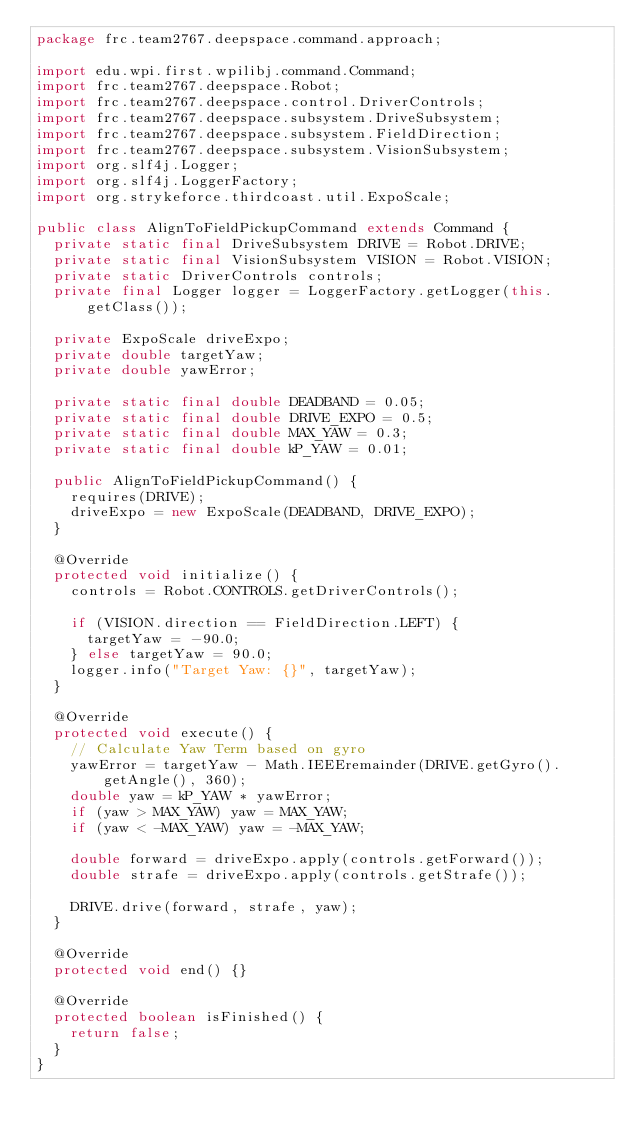<code> <loc_0><loc_0><loc_500><loc_500><_Java_>package frc.team2767.deepspace.command.approach;

import edu.wpi.first.wpilibj.command.Command;
import frc.team2767.deepspace.Robot;
import frc.team2767.deepspace.control.DriverControls;
import frc.team2767.deepspace.subsystem.DriveSubsystem;
import frc.team2767.deepspace.subsystem.FieldDirection;
import frc.team2767.deepspace.subsystem.VisionSubsystem;
import org.slf4j.Logger;
import org.slf4j.LoggerFactory;
import org.strykeforce.thirdcoast.util.ExpoScale;

public class AlignToFieldPickupCommand extends Command {
  private static final DriveSubsystem DRIVE = Robot.DRIVE;
  private static final VisionSubsystem VISION = Robot.VISION;
  private static DriverControls controls;
  private final Logger logger = LoggerFactory.getLogger(this.getClass());

  private ExpoScale driveExpo;
  private double targetYaw;
  private double yawError;

  private static final double DEADBAND = 0.05;
  private static final double DRIVE_EXPO = 0.5;
  private static final double MAX_YAW = 0.3;
  private static final double kP_YAW = 0.01;

  public AlignToFieldPickupCommand() {
    requires(DRIVE);
    driveExpo = new ExpoScale(DEADBAND, DRIVE_EXPO);
  }

  @Override
  protected void initialize() {
    controls = Robot.CONTROLS.getDriverControls();

    if (VISION.direction == FieldDirection.LEFT) {
      targetYaw = -90.0;
    } else targetYaw = 90.0;
    logger.info("Target Yaw: {}", targetYaw);
  }

  @Override
  protected void execute() {
    // Calculate Yaw Term based on gyro
    yawError = targetYaw - Math.IEEEremainder(DRIVE.getGyro().getAngle(), 360);
    double yaw = kP_YAW * yawError;
    if (yaw > MAX_YAW) yaw = MAX_YAW;
    if (yaw < -MAX_YAW) yaw = -MAX_YAW;

    double forward = driveExpo.apply(controls.getForward());
    double strafe = driveExpo.apply(controls.getStrafe());

    DRIVE.drive(forward, strafe, yaw);
  }

  @Override
  protected void end() {}

  @Override
  protected boolean isFinished() {
    return false;
  }
}
</code> 